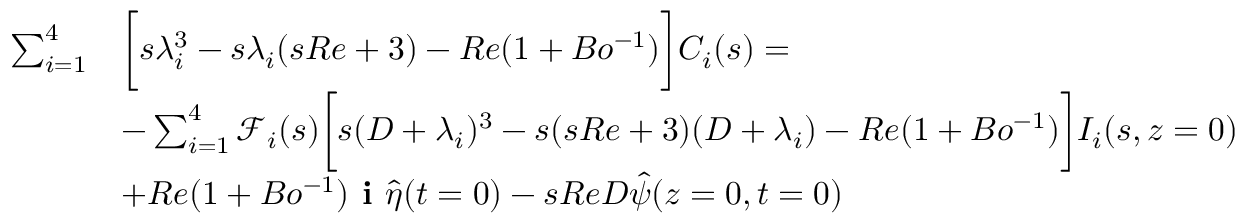<formula> <loc_0><loc_0><loc_500><loc_500>\begin{array} { r l } { \sum _ { i = 1 } ^ { 4 } } & { \left [ s \lambda _ { i } ^ { 3 } - s \lambda _ { i } ( s R e + 3 ) - R e ( 1 + B o ^ { - 1 } ) \right ] C _ { i } ( s ) = } \\ & { - \sum _ { i = 1 } ^ { 4 } \ m a t h s c r { F } _ { i } ( s ) \left [ s ( D + \lambda _ { i } ) ^ { 3 } - s ( s R e + 3 ) ( D + \lambda _ { i } ) - R e ( 1 + B o ^ { - 1 } ) \right ] I _ { i } ( s , z = 0 ) } \\ & { + R e ( 1 + B o ^ { - 1 } ) i \hat { \eta } ( t = 0 ) - s R e D \hat { \psi } ( z = 0 , t = 0 ) } \end{array}</formula> 